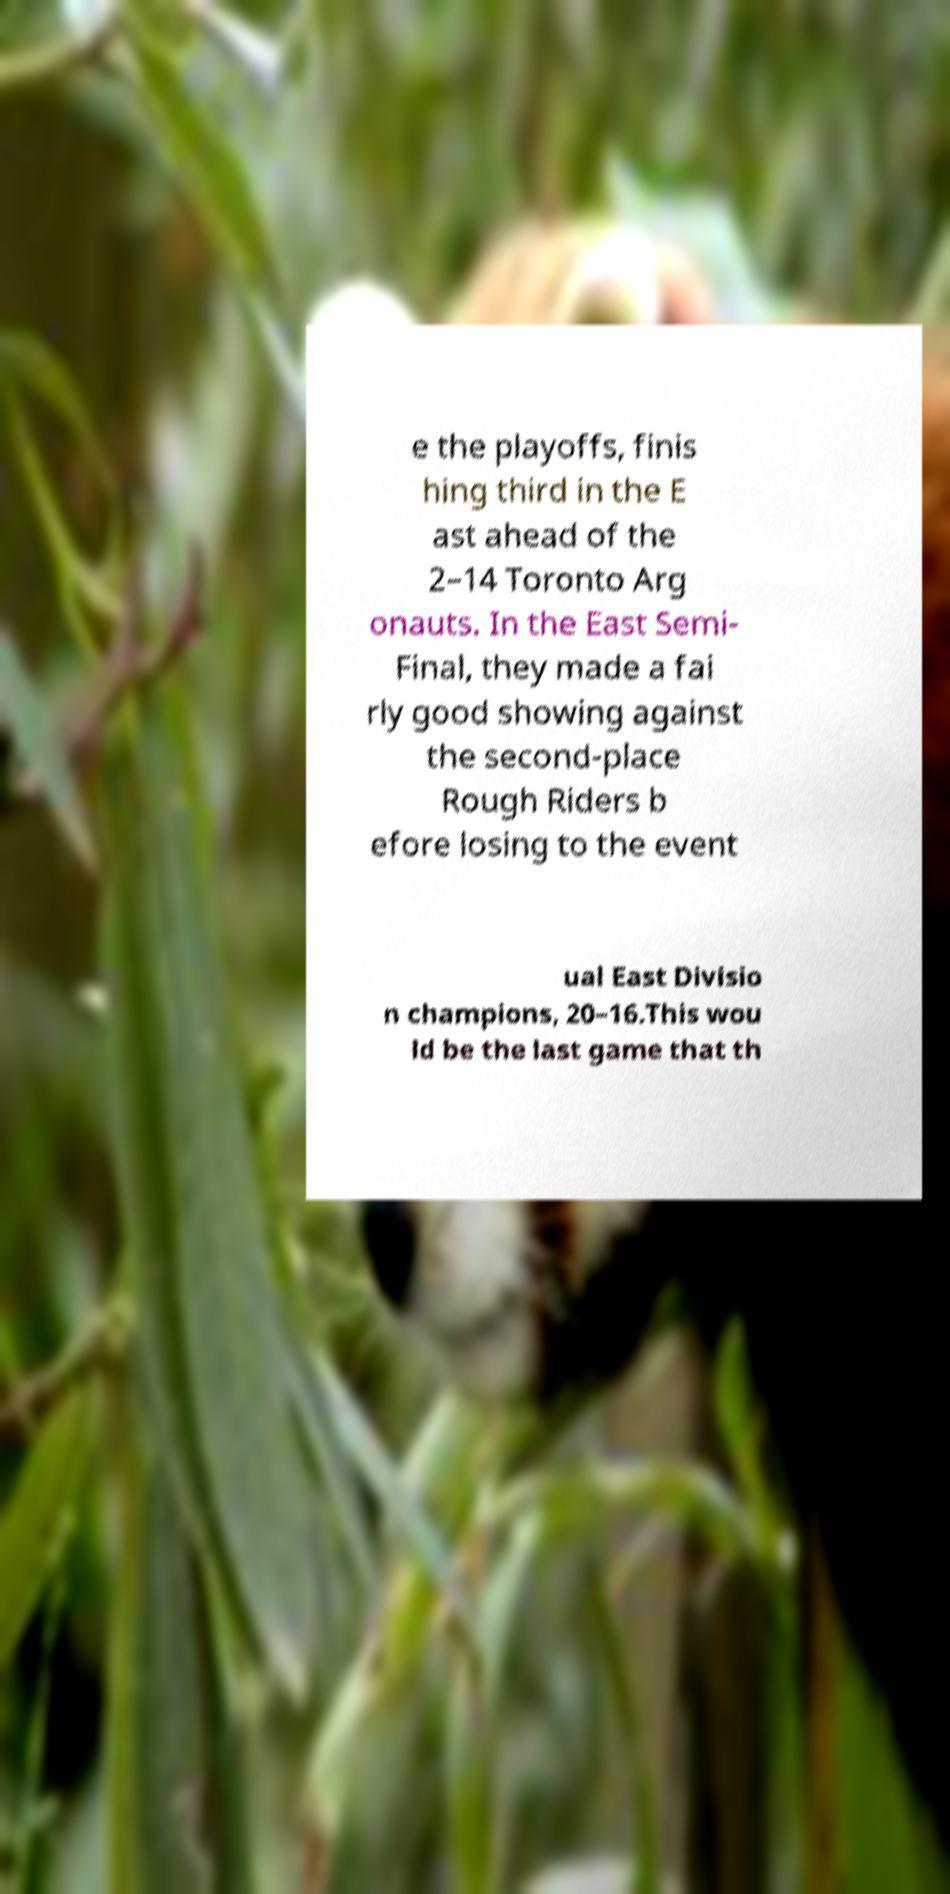For documentation purposes, I need the text within this image transcribed. Could you provide that? e the playoffs, finis hing third in the E ast ahead of the 2–14 Toronto Arg onauts. In the East Semi- Final, they made a fai rly good showing against the second-place Rough Riders b efore losing to the event ual East Divisio n champions, 20–16.This wou ld be the last game that th 